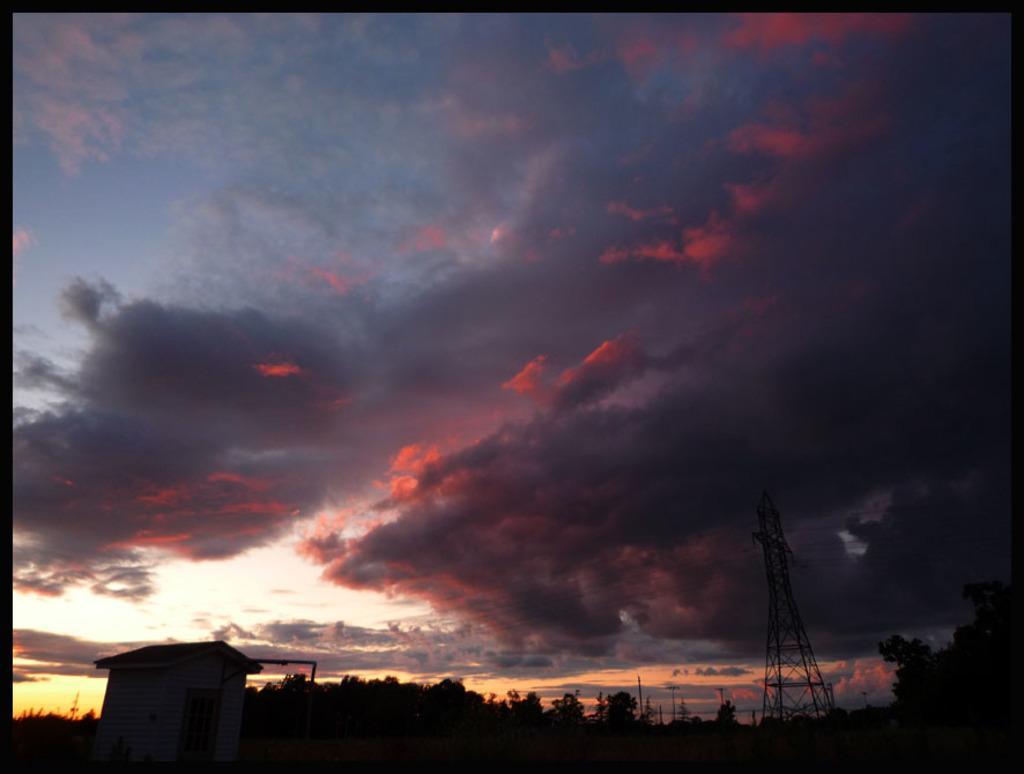Please provide a concise description of this image. This image is taken outdoors. At the top of the image there is a sky with clouds. At the bottom of the image there are many trees and plants. There is a tower and a hut. 